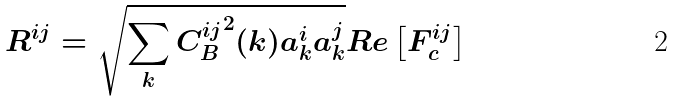Convert formula to latex. <formula><loc_0><loc_0><loc_500><loc_500>R ^ { i j } = \sqrt { \sum _ { k } { C ^ { i j } _ { B } } ^ { 2 } ( k ) a _ { k } ^ { i } a _ { k } ^ { j } } R e \left [ F _ { c } ^ { i j } \right ]</formula> 